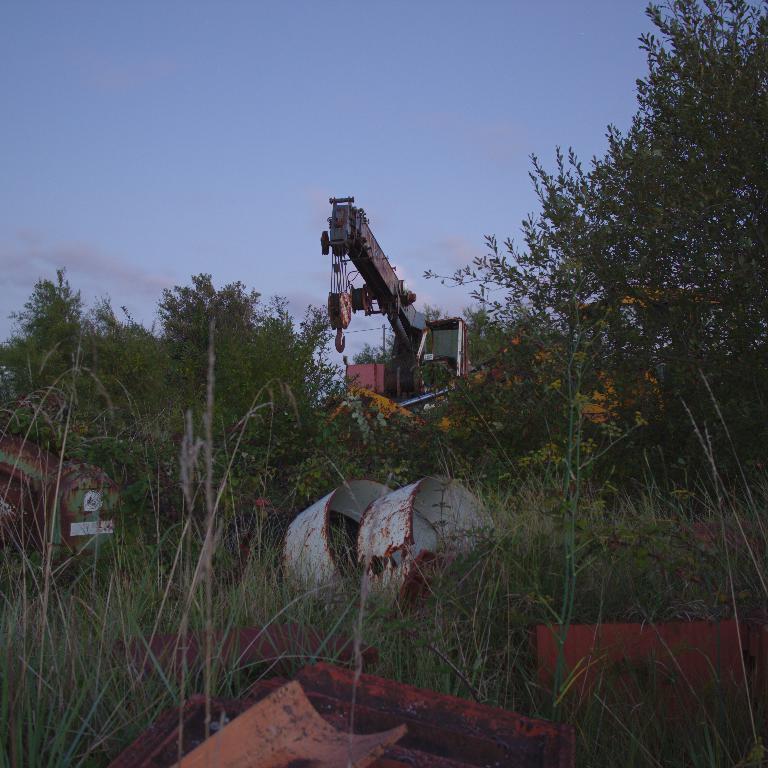In one or two sentences, can you explain what this image depicts? In this image, we can see a crane in between trees. There is a scrap at the bottom of the image. In the background of the image, there is a sky. 